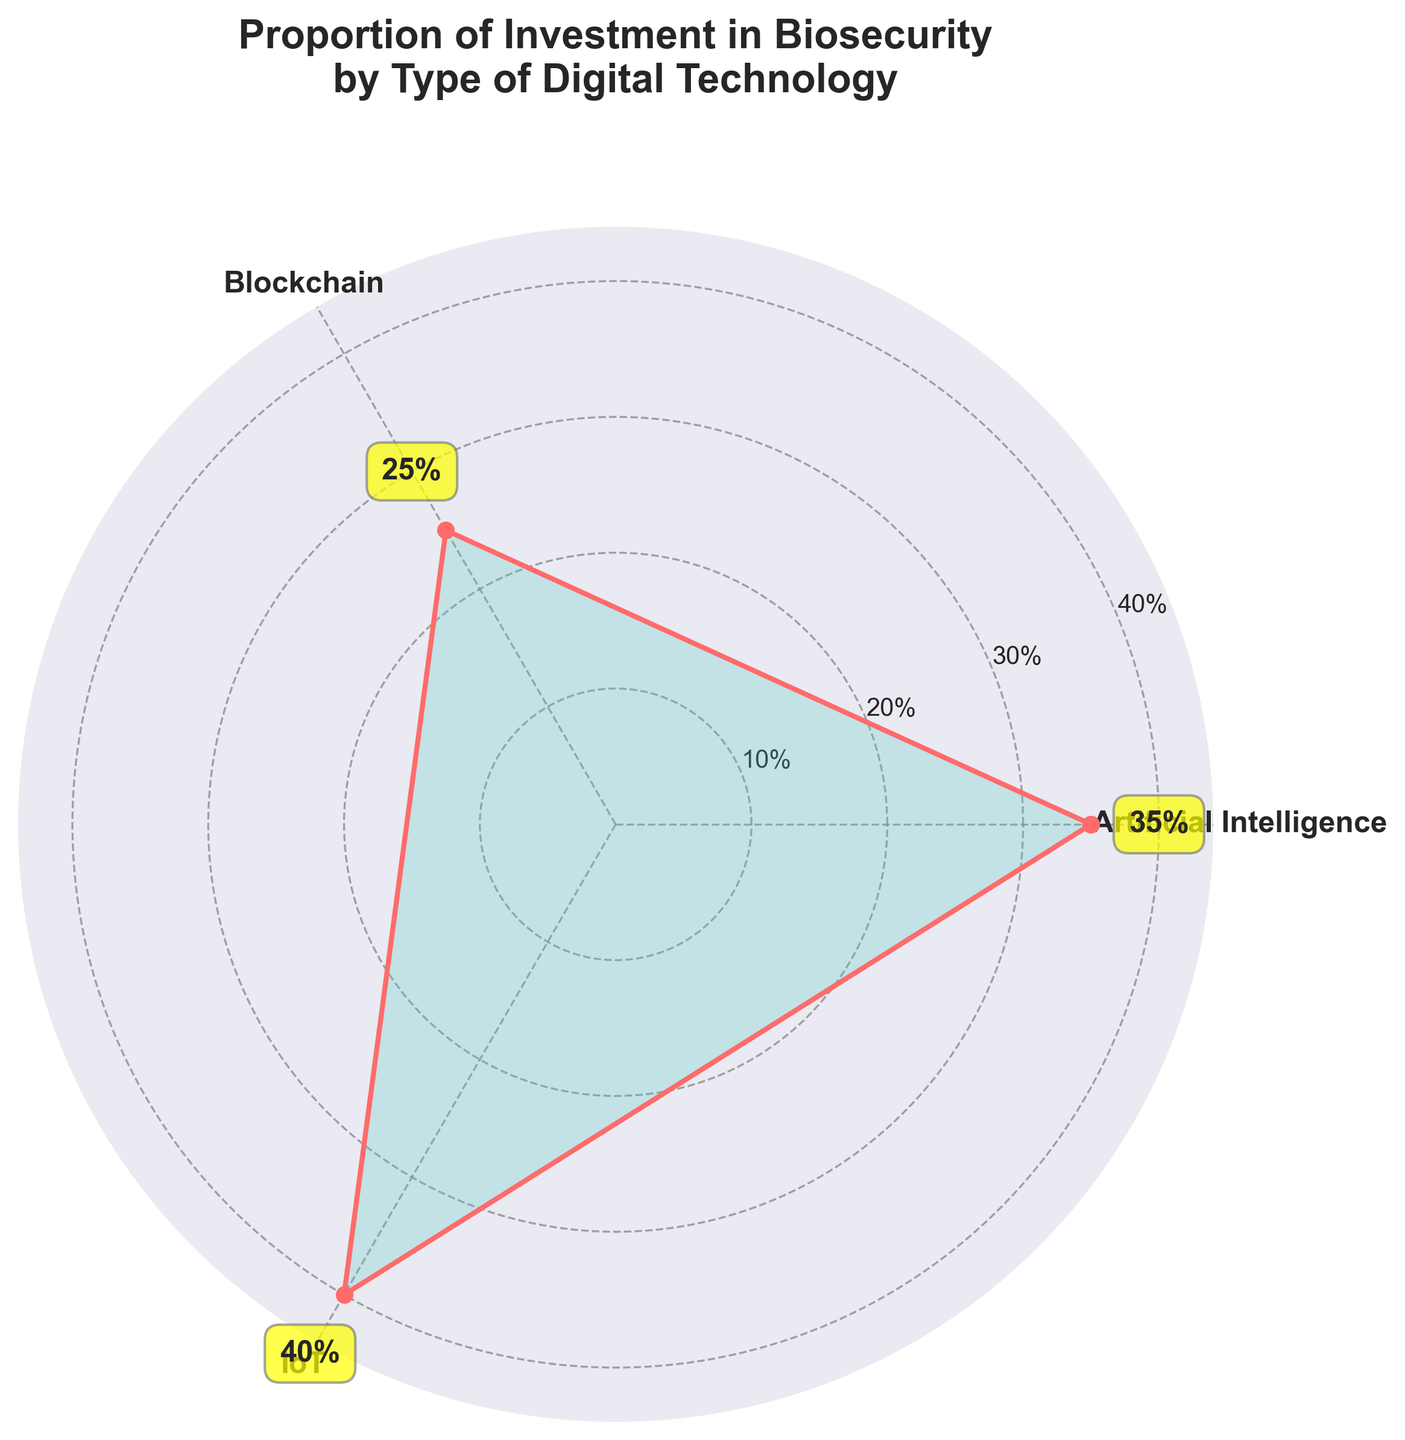What's the title of the figure? The title is written at the top of the figure and clearly states the main focus of the data presentation.
Answer: Proportion of Investment in Biosecurity by Type of Digital Technology How many categories of digital technologies are shown in the figure? The figure includes distinct categories labeled around the polar plot.
Answer: 3 Which digital technology category has the highest investment? By observing the height of the area on the plot, the highest point represents the highest investment.
Answer: IoT What is the proportion of investment in Blockchain? The figure includes value annotations near each category label; for Blockchain, it is specifically marked.
Answer: 25% How do the investments in Artificial Intelligence and Blockchain compare? Look at the value annotations for each category and note the difference. Artificial Intelligence has 35%, and Blockchain has 25%, so Blockchain has less investment.
Answer: Artificial Intelligence has higher investment What is the sum of investments in Artificial Intelligence and IoT? Sum the values for Artificial Intelligence (35%) and IoT (40%).
Answer: 75% What is the average investment across all digital technology categories? Sum the values of all categories (calculate 35% + 25% + 40%) and divide by the total number of categories (3).
Answer: 33.33% In which category is the proportional investment closer to the average value? Calculate the average (33.33%) and compare it to the values of each category: Artificial Intelligence (35%), Blockchain (25%), and IoT (40%). Artificial Intelligence (35%) is closest to the average.
Answer: Artificial Intelligence Which categories' combined investments equal the same total as the majority category's investment? Identify the majority category's investment (IoT, 40%) and find a combination of two other values that equal it. Combining Artificial Intelligence (35%) and Blockchain (25%) sums to 60%, which does not match any single category.
Answer: None 